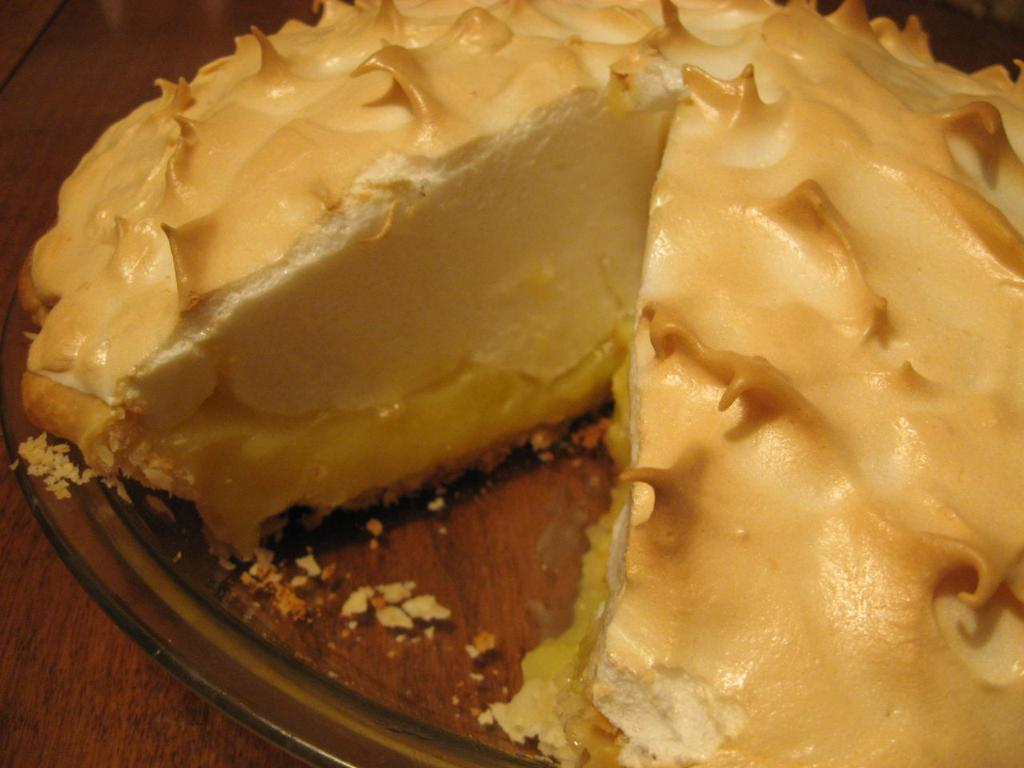What type of bowl is visible in the image? There is a glass bowl in the image. What is inside the glass bowl? There is cheesecake in the bowl. What material is the surface at the bottom of the image? The surface at the bottom of the image is wooden. Where is the meeting taking place in the image? There is no meeting taking place in the image; it only shows a glass bowl with cheesecake on a wooden surface. 